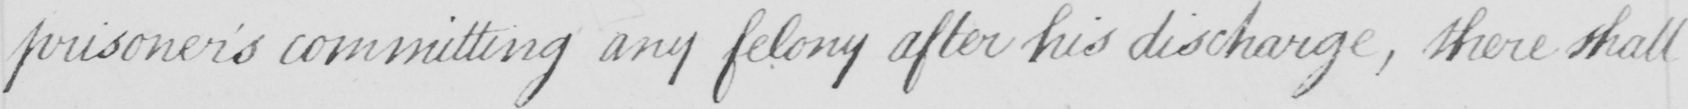Please provide the text content of this handwritten line. prisoner ' s committing any felony after his discharge , there shall 